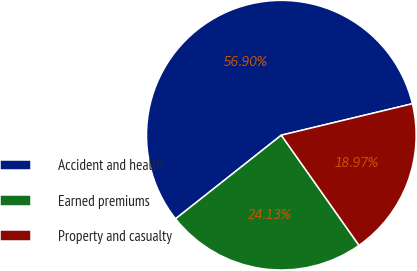Convert chart to OTSL. <chart><loc_0><loc_0><loc_500><loc_500><pie_chart><fcel>Accident and health<fcel>Earned premiums<fcel>Property and casualty<nl><fcel>56.9%<fcel>24.13%<fcel>18.97%<nl></chart> 